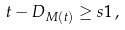Convert formula to latex. <formula><loc_0><loc_0><loc_500><loc_500>t - D _ { M ( t ) } \geq s 1 \, ,</formula> 